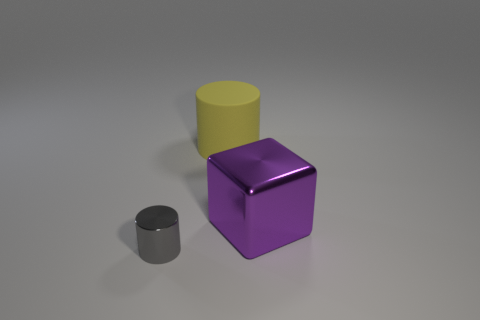Add 1 yellow matte things. How many objects exist? 4 Subtract all cubes. How many objects are left? 2 Subtract 0 red cubes. How many objects are left? 3 Subtract all shiny spheres. Subtract all large purple blocks. How many objects are left? 2 Add 2 small gray metallic cylinders. How many small gray metallic cylinders are left? 3 Add 3 tiny cylinders. How many tiny cylinders exist? 4 